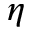<formula> <loc_0><loc_0><loc_500><loc_500>\eta</formula> 